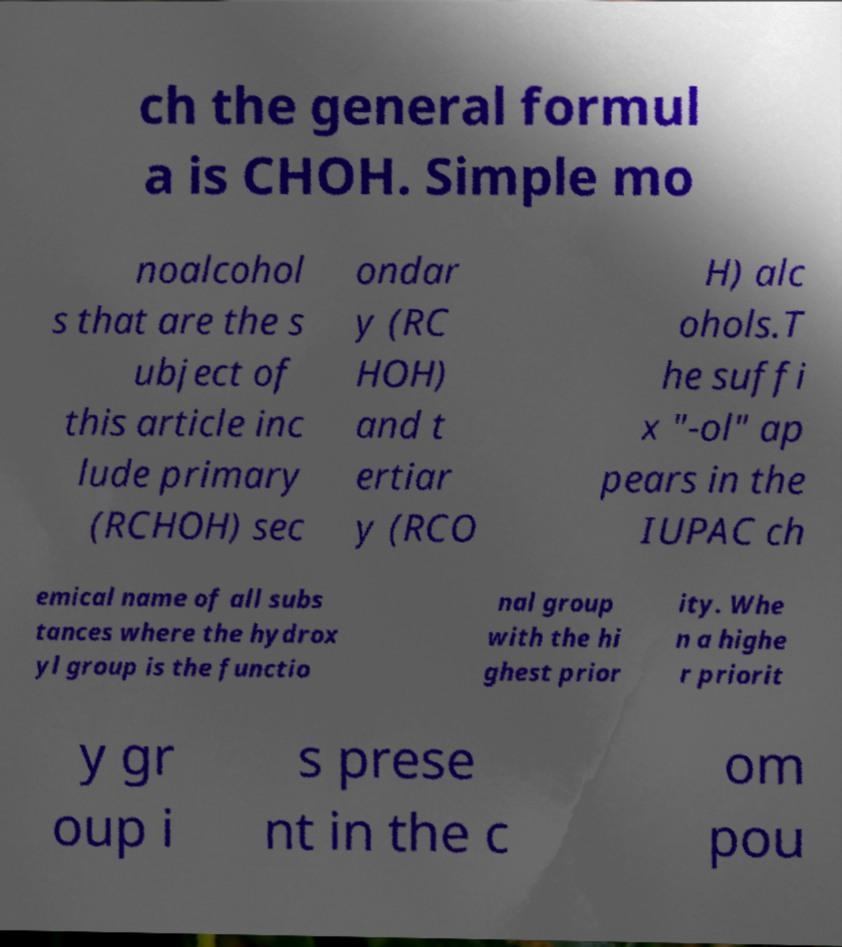Please identify and transcribe the text found in this image. ch the general formul a is CHOH. Simple mo noalcohol s that are the s ubject of this article inc lude primary (RCHOH) sec ondar y (RC HOH) and t ertiar y (RCO H) alc ohols.T he suffi x "-ol" ap pears in the IUPAC ch emical name of all subs tances where the hydrox yl group is the functio nal group with the hi ghest prior ity. Whe n a highe r priorit y gr oup i s prese nt in the c om pou 